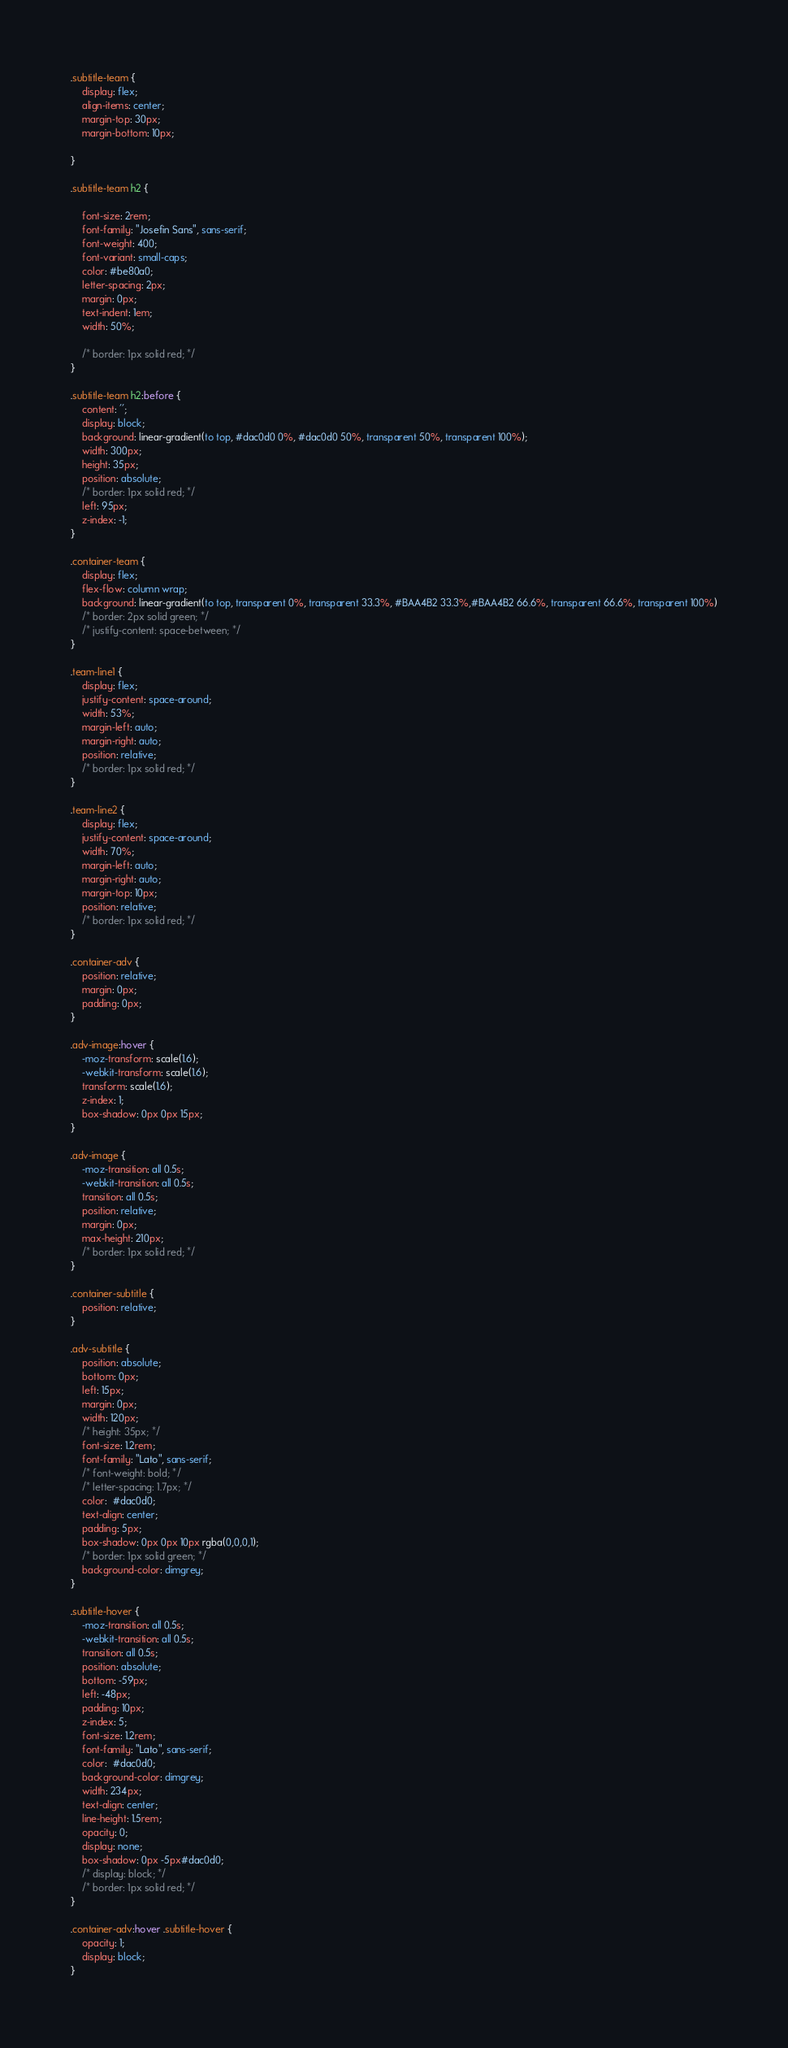<code> <loc_0><loc_0><loc_500><loc_500><_CSS_>.subtitle-team {
    display: flex;
    align-items: center;
    margin-top: 30px;
    margin-bottom: 10px;
    
}

.subtitle-team h2 {
    
    font-size: 2rem;
    font-family: "Josefin Sans", sans-serif;
    font-weight: 400;
    font-variant: small-caps;
    color: #be80a0; 
    letter-spacing: 2px;
    margin: 0px;
    text-indent: 1em; 
    width: 50%;

    /* border: 1px solid red; */
}

.subtitle-team h2:before {
    content: '';
    display: block;
    background: linear-gradient(to top, #dac0d0 0%, #dac0d0 50%, transparent 50%, transparent 100%);
    width: 300px;
    height: 35px;
    position: absolute;
    /* border: 1px solid red; */
    left: 95px;
    z-index: -1;
}

.container-team {
    display: flex;
    flex-flow: column wrap;
    background: linear-gradient(to top, transparent 0%, transparent 33.3%, #BAA4B2 33.3%,#BAA4B2 66.6%, transparent 66.6%, transparent 100%)
    /* border: 2px solid green; */
    /* justify-content: space-between; */
}

.team-line1 {
    display: flex;
    justify-content: space-around;
    width: 53%;
    margin-left: auto;
    margin-right: auto;
    position: relative;
    /* border: 1px solid red; */
}

.team-line2 {
    display: flex;
    justify-content: space-around;
    width: 70%;
    margin-left: auto;
    margin-right: auto;
    margin-top: 10px;
    position: relative;
    /* border: 1px solid red; */
}

.container-adv {
    position: relative;
    margin: 0px;
    padding: 0px;
}

.adv-image:hover {
    -moz-transform: scale(1.6);
    -webkit-transform: scale(1.6);
    transform: scale(1.6);
    z-index: 1;
    box-shadow: 0px 0px 15px;
}

.adv-image {    
    -moz-transition: all 0.5s;
    -webkit-transition: all 0.5s;
    transition: all 0.5s;
    position: relative;
    margin: 0px;
    max-height: 210px;
    /* border: 1px solid red; */
}

.container-subtitle {
    position: relative;
}

.adv-subtitle {
    position: absolute;
    bottom: 0px;
    left: 15px;
    margin: 0px;
    width: 120px;
    /* height: 35px; */
    font-size: 1.2rem;
    font-family: "Lato", sans-serif;
    /* font-weight: bold; */
    /* letter-spacing: 1.7px; */
    color:  #dac0d0;
    text-align: center;
    padding: 5px;
    box-shadow: 0px 0px 10px rgba(0,0,0,1);
    /* border: 1px solid green; */
    background-color: dimgrey;
}

.subtitle-hover {
    -moz-transition: all 0.5s;
    -webkit-transition: all 0.5s;
    transition: all 0.5s;
    position: absolute;
    bottom: -59px;
    left: -48px;
    padding: 10px;
    z-index: 5;
    font-size: 1.2rem;
    font-family: "Lato", sans-serif;
    color:  #dac0d0;
    background-color: dimgrey;
    width: 234px;
    text-align: center;
    line-height: 1.5rem;
    opacity: 0;
    display: none;
    box-shadow: 0px -5px#dac0d0;
    /* display: block; */
    /* border: 1px solid red; */
}

.container-adv:hover .subtitle-hover {
    opacity: 1;
    display: block;
}
</code> 